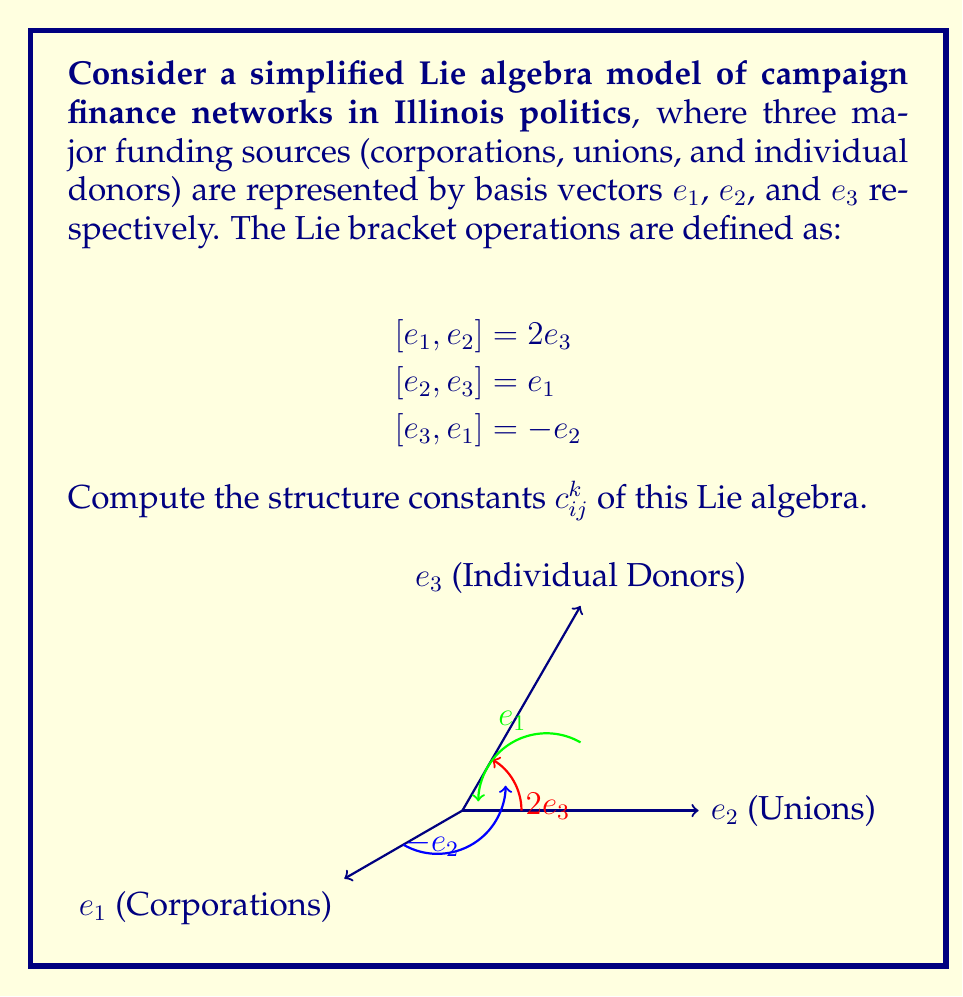What is the answer to this math problem? To compute the structure constants of this Lie algebra, we need to express each Lie bracket operation in terms of the structure constants:

$$[e_i, e_j] = \sum_{k=1}^3 c_{ij}^k e_k$$

Step 1: Analyze $[e_1, e_2] = 2e_3$
This implies:
$c_{12}^1 = 0$
$c_{12}^2 = 0$
$c_{12}^3 = 2$

Step 2: Analyze $[e_2, e_3] = e_1$
This implies:
$c_{23}^1 = 1$
$c_{23}^2 = 0$
$c_{23}^3 = 0$

Step 3: Analyze $[e_3, e_1] = -e_2$
This implies:
$c_{31}^1 = 0$
$c_{31}^2 = -1$
$c_{31}^3 = 0$

Step 4: Use the antisymmetry property of Lie brackets
$[e_i, e_j] = -[e_j, e_i]$, which means $c_{ij}^k = -c_{ji}^k$

Therefore:
$c_{21}^3 = -2$
$c_{32}^1 = -1$
$c_{13}^2 = 1$

All other structure constants are zero.

Step 5: Organize the results into a 3x3x3 array
$c_{ij}^k$ can be represented as:

For $k=1$: 
$$\begin{pmatrix}
0 & 0 & 0 \\
0 & 0 & 1 \\
0 & -1 & 0
\end{pmatrix}$$

For $k=2$:
$$\begin{pmatrix}
0 & 0 & 1 \\
0 & 0 & 0 \\
-1 & 0 & 0
\end{pmatrix}$$

For $k=3$:
$$\begin{pmatrix}
0 & 2 & 0 \\
-2 & 0 & 0 \\
0 & 0 & 0
\end{pmatrix}$$
Answer: $c_{12}^3 = 2$, $c_{23}^1 = 1$, $c_{31}^2 = -1$, $c_{21}^3 = -2$, $c_{32}^1 = -1$, $c_{13}^2 = 1$; all others are zero. 